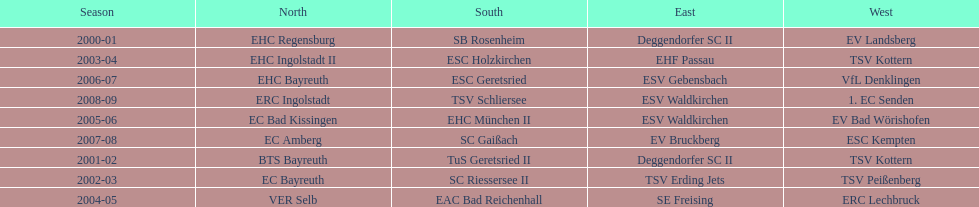The last team to win the west? 1. EC Senden. 